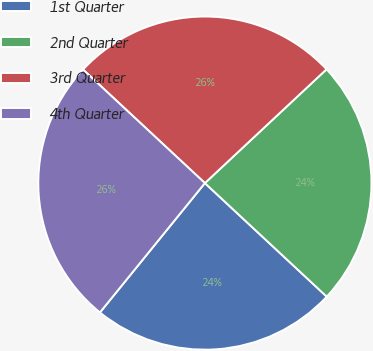Convert chart. <chart><loc_0><loc_0><loc_500><loc_500><pie_chart><fcel>1st Quarter<fcel>2nd Quarter<fcel>3rd Quarter<fcel>4th Quarter<nl><fcel>23.91%<fcel>23.91%<fcel>26.09%<fcel>26.09%<nl></chart> 